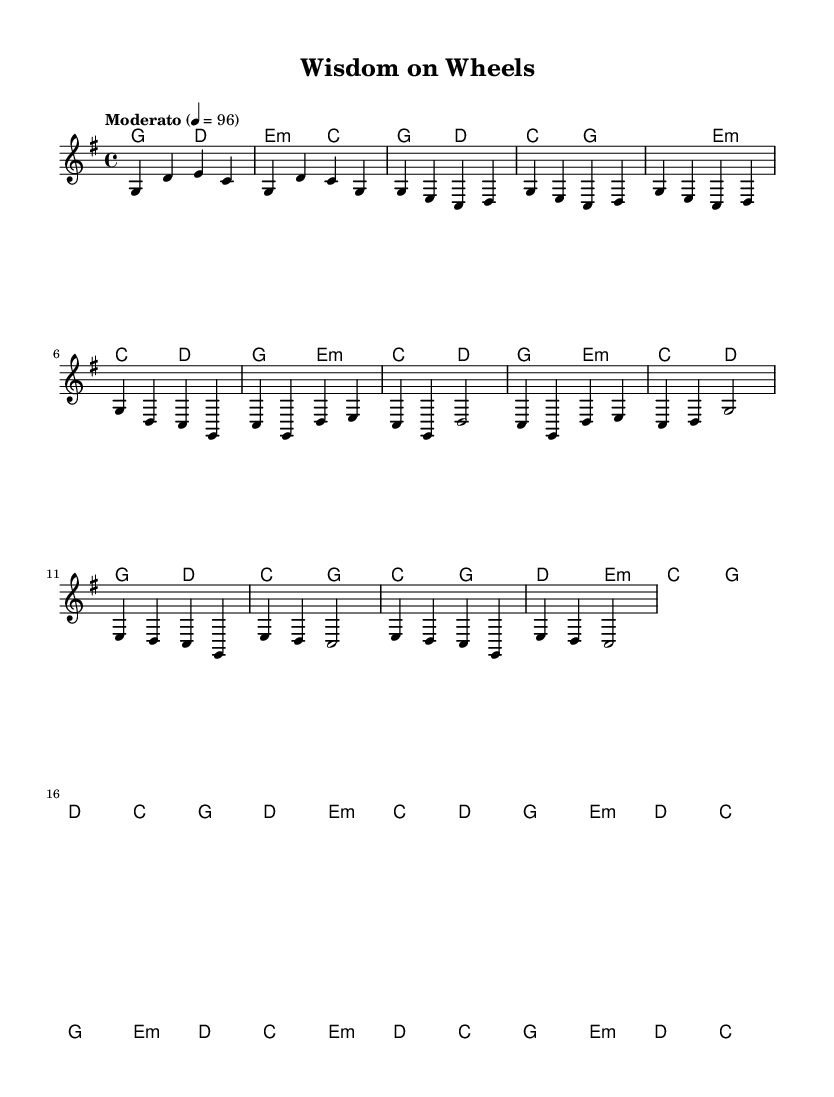What is the key signature of this music? The key signature is G major, which has one sharp (F#). This is evident from the key indication at the beginning of the score.
Answer: G major What is the time signature of this music? The time signature is 4/4, which can be seen at the start of the score, indicating four beats per measure with a quarter note receiving one beat.
Answer: 4/4 What is the tempo marking for this piece? The tempo marking is "Moderato," and it indicates a moderate speed. The specific beats per minute (BPM) are also noted as 96, providing a precise tempo.
Answer: Moderato How many measures are in the chorus section? The chorus section consists of 4 measures as it is labeled appropriately in the score, which can be counted sequentially from the beginning of the chorus segment to the end.
Answer: 4 What is the harmonic structure of the first chord in the intro? The first chord in the intro is G major, which is indicated by the corresponding chord symbol under the staff. This chord serves as the tonic in G major.
Answer: G What are the two main themes present in the lyrics? The two main themes reflected in the lyrics are the wisdom of older generations and the experiences of youth. This can be inferred from the overall context of the song's title and implications.
Answer: Wisdom and experience How does the bridge section transition harmonically? The bridge transitions from E minor to D major and then back to C major. This sequence creates a descending line, marking a shift in emotional depth before returning to the main theme.
Answer: E minor to D to C major 